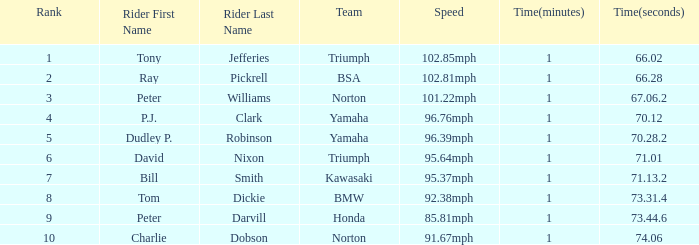Which Rider has a 1:06.02.0 Time? Tony Jefferies. 